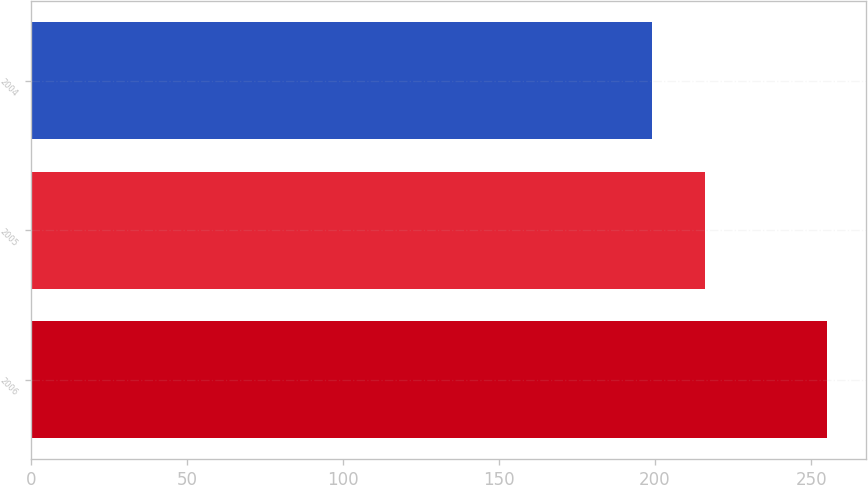Convert chart to OTSL. <chart><loc_0><loc_0><loc_500><loc_500><bar_chart><fcel>2006<fcel>2005<fcel>2004<nl><fcel>255<fcel>216<fcel>199<nl></chart> 